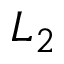<formula> <loc_0><loc_0><loc_500><loc_500>L _ { 2 }</formula> 